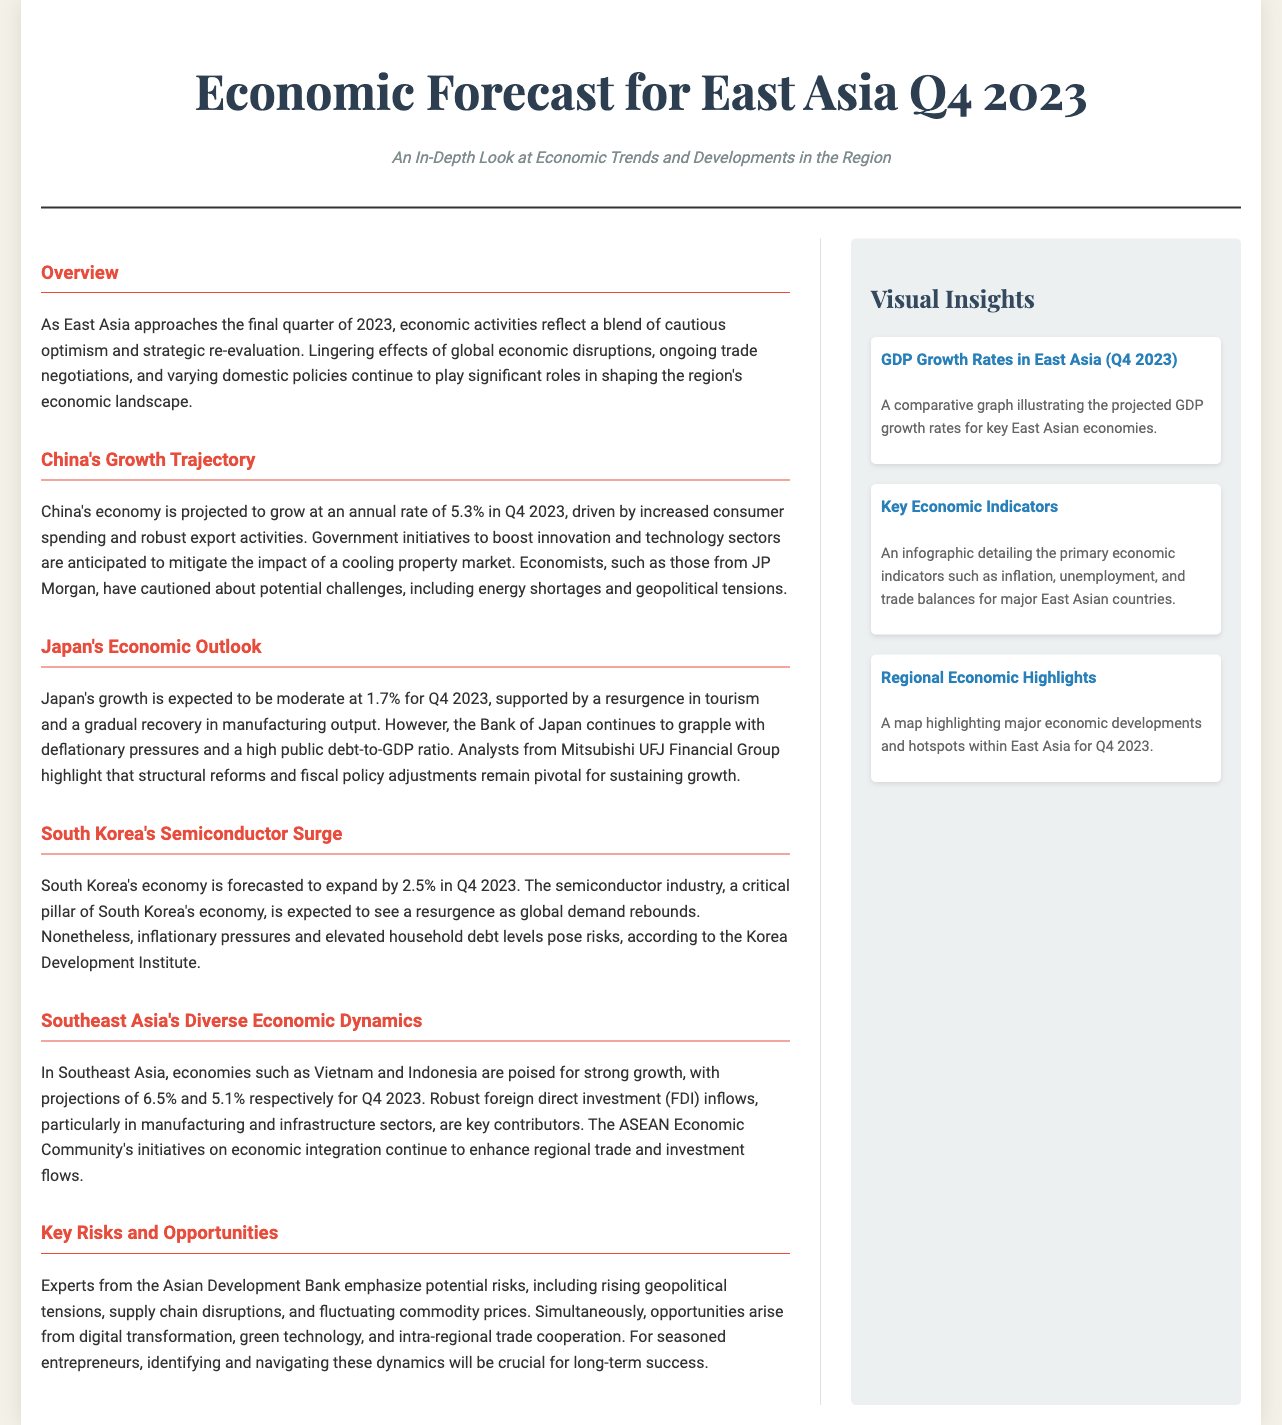What is the projected growth rate for China's economy in Q4 2023? The document states that China's economy is projected to grow at an annual rate of 5.3% in Q4 2023.
Answer: 5.3% What is Japan's expected growth rate for Q4 2023? The article mentions that Japan's growth is expected to be moderate at 1.7% for Q4 2023.
Answer: 1.7% Which country in Southeast Asia is projected to grow at 6.5% in Q4 2023? The document identifies Vietnam as poised for strong growth at 6.5% in Q4 2023.
Answer: Vietnam What is a key challenge mentioned for South Korea's economy? The analysis notes that inflationary pressures and elevated household debt levels pose risks.
Answer: Inflationary pressures What opportunities are highlighted for seasoned entrepreneurs in East Asia? The text emphasizes opportunities arising from digital transformation, green technology, and intra-regional trade cooperation.
Answer: Digital transformation What are the two main factors driving China's economic growth? It is indicated that increased consumer spending and robust export activities are driving China's growth.
Answer: Consumer spending and export activities What organization provided insights on potential economic risks? The Asian Development Bank is mentioned as the source of insights regarding potential risks.
Answer: Asian Development Bank Which economic sector in South Korea is expected to see a resurgence? The document states that the semiconductor industry is forecasted to see a resurgence.
Answer: Semiconductor industry What is the projected growth rate for South Korea's economy in Q4 2023? The document forecasts South Korea's economy to expand by 2.5% in Q4 2023.
Answer: 2.5% 